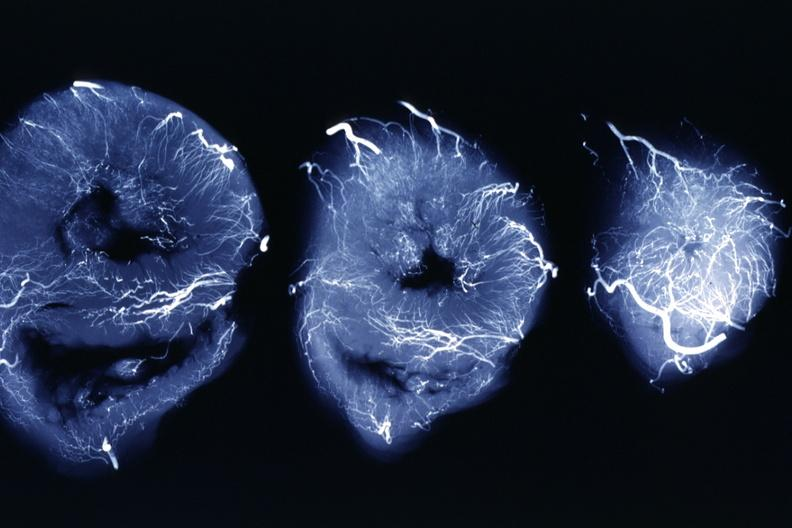does this image show x-ray three horizontal slices of ventricles showing quite well the penetrating arteries?
Answer the question using a single word or phrase. Yes 